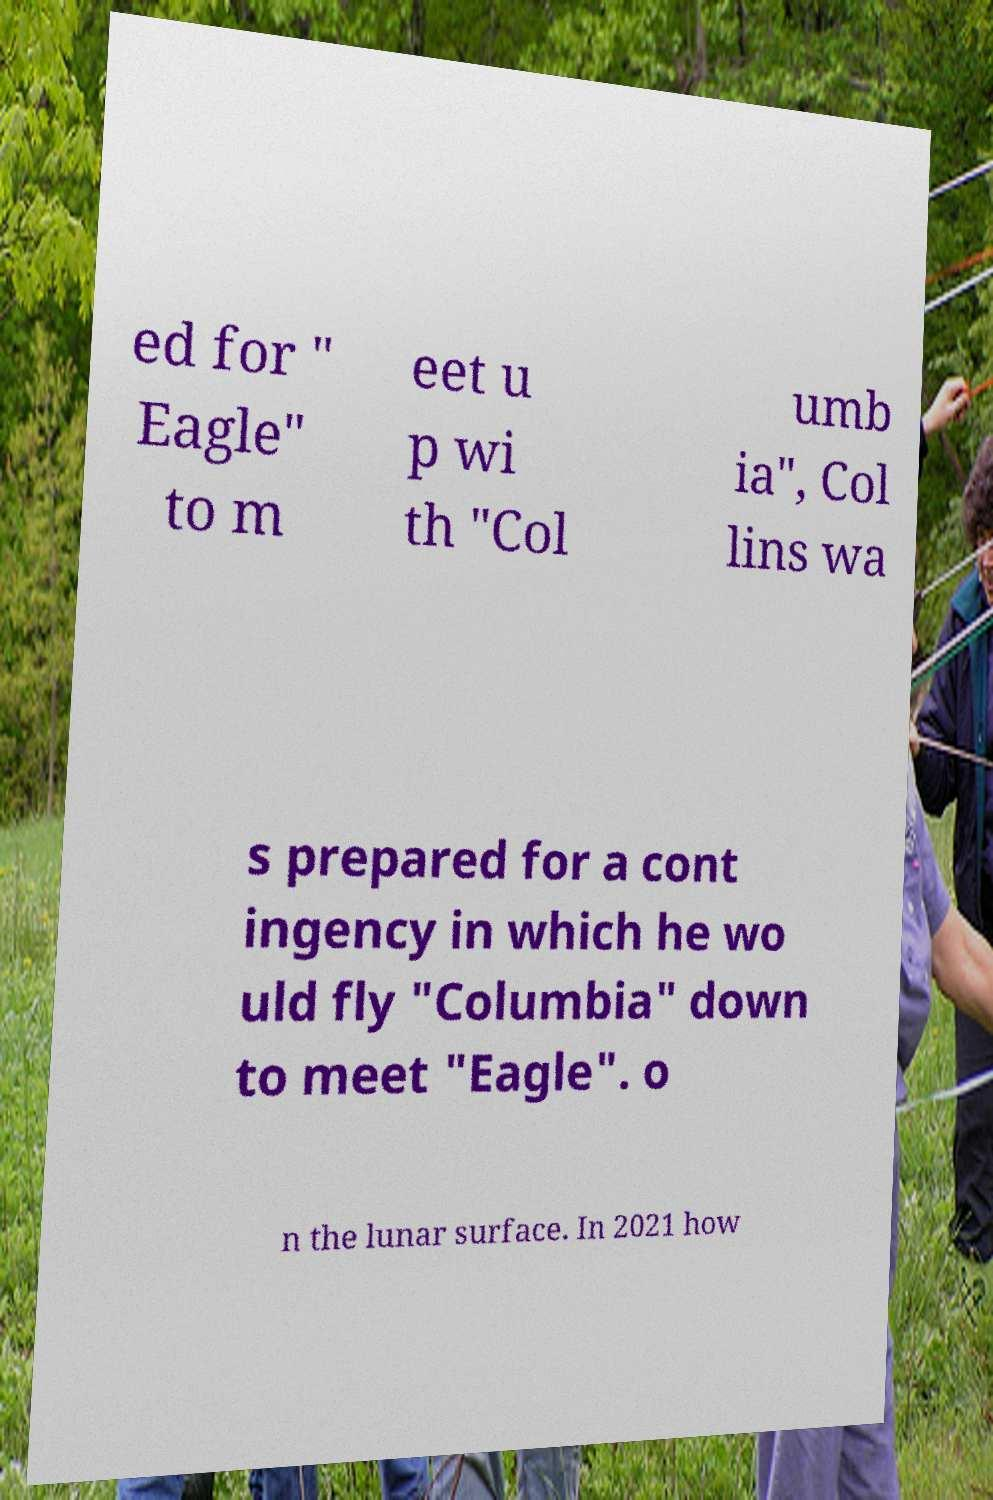Please identify and transcribe the text found in this image. ed for " Eagle" to m eet u p wi th "Col umb ia", Col lins wa s prepared for a cont ingency in which he wo uld fly "Columbia" down to meet "Eagle". o n the lunar surface. In 2021 how 